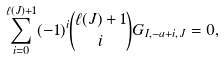Convert formula to latex. <formula><loc_0><loc_0><loc_500><loc_500>\sum _ { i = 0 } ^ { \ell ( J ) + 1 } ( - 1 ) ^ { i } \binom { \ell ( J ) + 1 } { i } G _ { I , - a + i , J } = 0 ,</formula> 